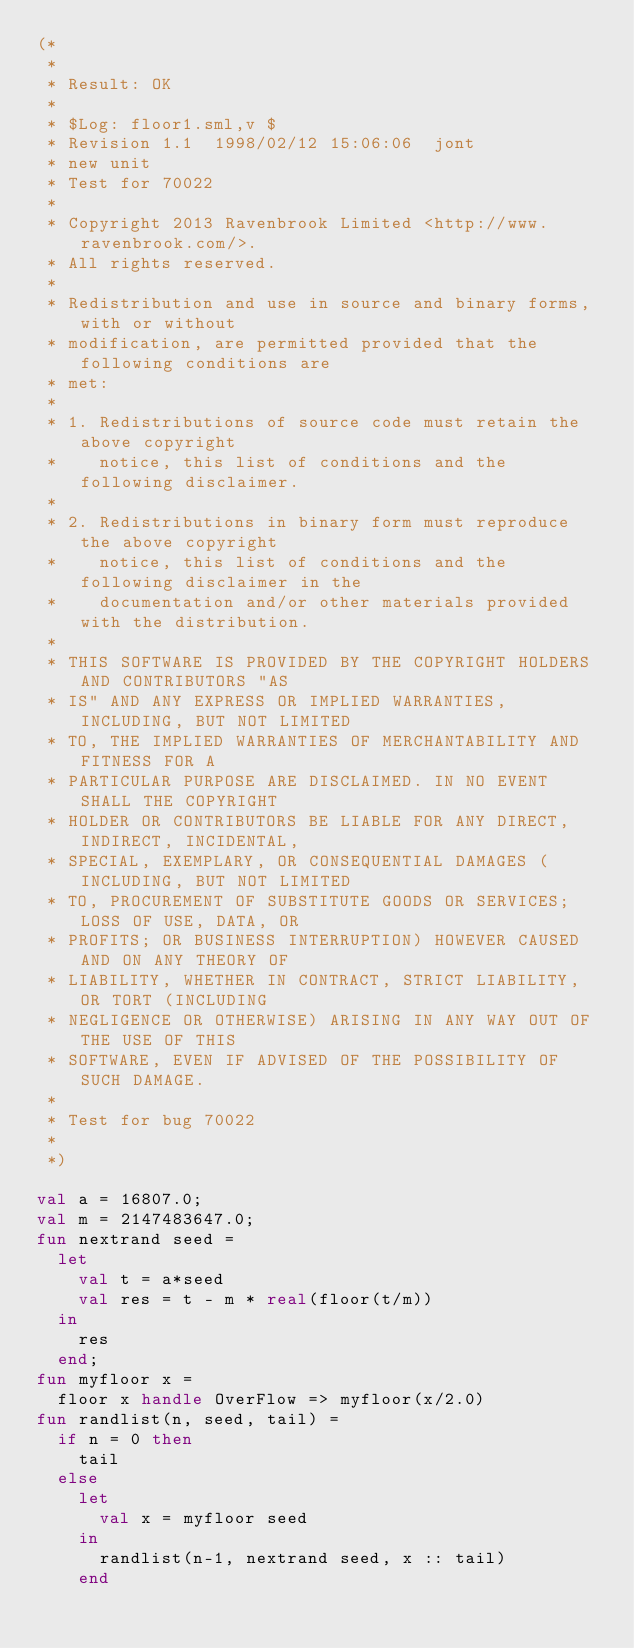Convert code to text. <code><loc_0><loc_0><loc_500><loc_500><_SML_>(*
 *
 * Result: OK
 *
 * $Log: floor1.sml,v $
 * Revision 1.1  1998/02/12 15:06:06  jont
 * new unit
 * Test for 70022
 *
 * Copyright 2013 Ravenbrook Limited <http://www.ravenbrook.com/>.
 * All rights reserved.
 * 
 * Redistribution and use in source and binary forms, with or without
 * modification, are permitted provided that the following conditions are
 * met:
 * 
 * 1. Redistributions of source code must retain the above copyright
 *    notice, this list of conditions and the following disclaimer.
 * 
 * 2. Redistributions in binary form must reproduce the above copyright
 *    notice, this list of conditions and the following disclaimer in the
 *    documentation and/or other materials provided with the distribution.
 * 
 * THIS SOFTWARE IS PROVIDED BY THE COPYRIGHT HOLDERS AND CONTRIBUTORS "AS
 * IS" AND ANY EXPRESS OR IMPLIED WARRANTIES, INCLUDING, BUT NOT LIMITED
 * TO, THE IMPLIED WARRANTIES OF MERCHANTABILITY AND FITNESS FOR A
 * PARTICULAR PURPOSE ARE DISCLAIMED. IN NO EVENT SHALL THE COPYRIGHT
 * HOLDER OR CONTRIBUTORS BE LIABLE FOR ANY DIRECT, INDIRECT, INCIDENTAL,
 * SPECIAL, EXEMPLARY, OR CONSEQUENTIAL DAMAGES (INCLUDING, BUT NOT LIMITED
 * TO, PROCUREMENT OF SUBSTITUTE GOODS OR SERVICES; LOSS OF USE, DATA, OR
 * PROFITS; OR BUSINESS INTERRUPTION) HOWEVER CAUSED AND ON ANY THEORY OF
 * LIABILITY, WHETHER IN CONTRACT, STRICT LIABILITY, OR TORT (INCLUDING
 * NEGLIGENCE OR OTHERWISE) ARISING IN ANY WAY OUT OF THE USE OF THIS
 * SOFTWARE, EVEN IF ADVISED OF THE POSSIBILITY OF SUCH DAMAGE.
 *
 * Test for bug 70022
 *
 *)

val a = 16807.0;
val m = 2147483647.0;
fun nextrand seed =
  let
    val t = a*seed
    val res = t - m * real(floor(t/m))
  in
    res
  end;
fun myfloor x =
  floor x handle OverFlow => myfloor(x/2.0)
fun randlist(n, seed, tail) =
  if n = 0 then
    tail
  else
    let
      val x = myfloor seed
    in
      randlist(n-1, nextrand seed, x :: tail)
    end</code> 